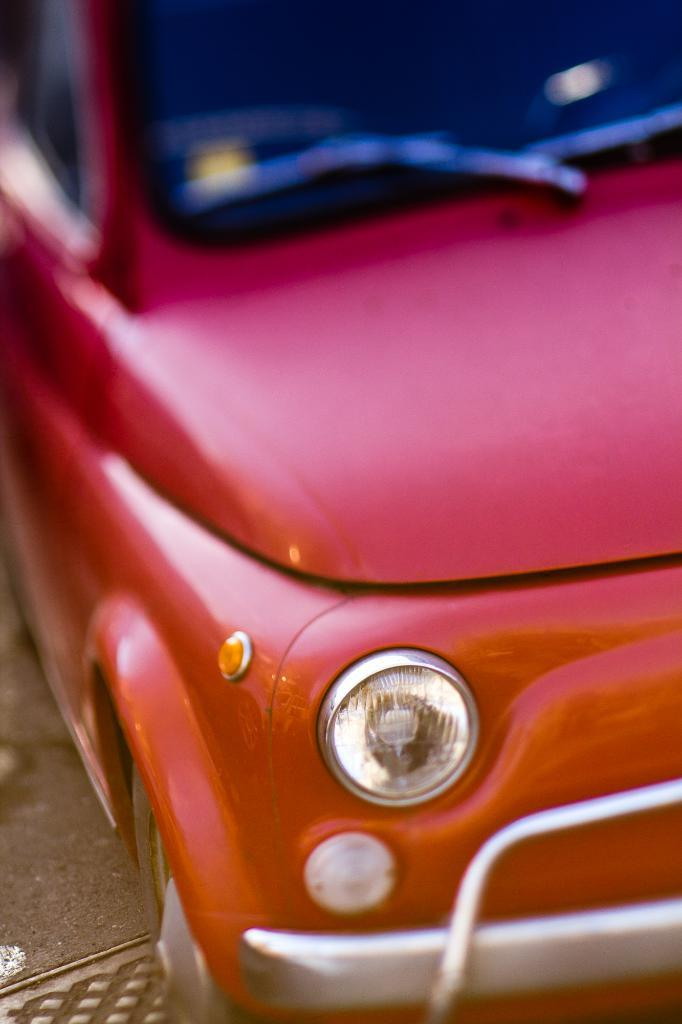What is the main subject of the image? The main subject of the image is a car. What is the car doing in the image? The car is parked in the image. What color is the car? The car is red in color. What type of soup is being served in the car? There is no soup present in the image; it features a parked red car. What operation is being performed on the car in the image? There is no operation being performed on the car in the image; it is simply parked. 